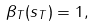<formula> <loc_0><loc_0><loc_500><loc_500>\beta _ { T } ( s _ { T } ) = 1 ,</formula> 